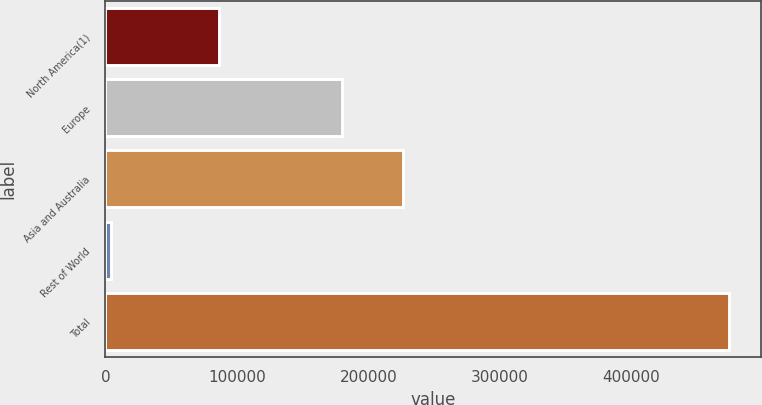<chart> <loc_0><loc_0><loc_500><loc_500><bar_chart><fcel>North America(1)<fcel>Europe<fcel>Asia and Australia<fcel>Rest of World<fcel>Total<nl><fcel>86181<fcel>179584<fcel>226636<fcel>3959<fcel>474482<nl></chart> 